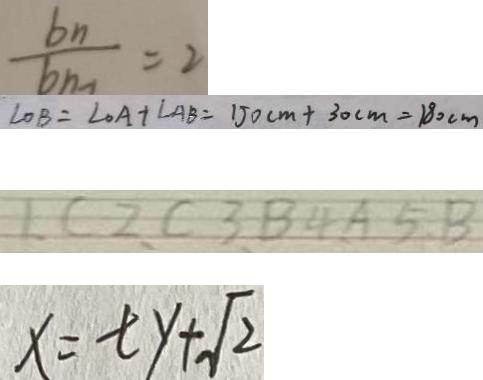<formula> <loc_0><loc_0><loc_500><loc_500>\frac { b _ { n } } { b _ { n - 1 } } = 2 
 \angle O B = \angle O A + \angle A B = 1 5 0 c m + 3 0 c m = 1 8 0 c m 
 1 , C 2 , C 3 , B , 4 A 5 , B 
 x = t y + \sqrt { 2 }</formula> 